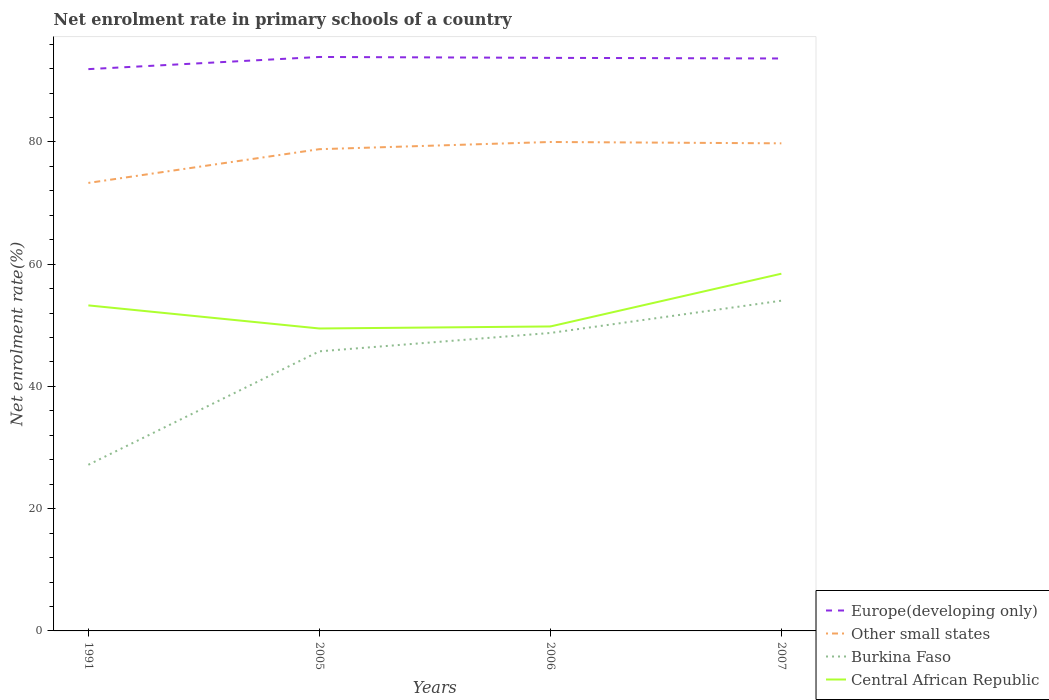Across all years, what is the maximum net enrolment rate in primary schools in Central African Republic?
Ensure brevity in your answer.  49.48. What is the total net enrolment rate in primary schools in Central African Republic in the graph?
Provide a short and direct response. 3.45. What is the difference between the highest and the second highest net enrolment rate in primary schools in Central African Republic?
Offer a terse response. 8.96. How many lines are there?
Your answer should be very brief. 4. How many years are there in the graph?
Make the answer very short. 4. Does the graph contain any zero values?
Give a very brief answer. No. Does the graph contain grids?
Your answer should be compact. No. How many legend labels are there?
Provide a short and direct response. 4. What is the title of the graph?
Provide a short and direct response. Net enrolment rate in primary schools of a country. Does "Portugal" appear as one of the legend labels in the graph?
Provide a short and direct response. No. What is the label or title of the X-axis?
Your answer should be compact. Years. What is the label or title of the Y-axis?
Keep it short and to the point. Net enrolment rate(%). What is the Net enrolment rate(%) in Europe(developing only) in 1991?
Make the answer very short. 91.91. What is the Net enrolment rate(%) in Other small states in 1991?
Offer a terse response. 73.29. What is the Net enrolment rate(%) in Burkina Faso in 1991?
Make the answer very short. 27.18. What is the Net enrolment rate(%) in Central African Republic in 1991?
Provide a succinct answer. 53.26. What is the Net enrolment rate(%) in Europe(developing only) in 2005?
Keep it short and to the point. 93.9. What is the Net enrolment rate(%) of Other small states in 2005?
Keep it short and to the point. 78.81. What is the Net enrolment rate(%) in Burkina Faso in 2005?
Your response must be concise. 45.74. What is the Net enrolment rate(%) of Central African Republic in 2005?
Your answer should be very brief. 49.48. What is the Net enrolment rate(%) in Europe(developing only) in 2006?
Make the answer very short. 93.76. What is the Net enrolment rate(%) in Other small states in 2006?
Ensure brevity in your answer.  79.99. What is the Net enrolment rate(%) in Burkina Faso in 2006?
Provide a succinct answer. 48.75. What is the Net enrolment rate(%) in Central African Republic in 2006?
Offer a very short reply. 49.81. What is the Net enrolment rate(%) of Europe(developing only) in 2007?
Your answer should be very brief. 93.65. What is the Net enrolment rate(%) of Other small states in 2007?
Your answer should be compact. 79.77. What is the Net enrolment rate(%) of Burkina Faso in 2007?
Your response must be concise. 54.03. What is the Net enrolment rate(%) of Central African Republic in 2007?
Your answer should be compact. 58.44. Across all years, what is the maximum Net enrolment rate(%) of Europe(developing only)?
Keep it short and to the point. 93.9. Across all years, what is the maximum Net enrolment rate(%) in Other small states?
Keep it short and to the point. 79.99. Across all years, what is the maximum Net enrolment rate(%) of Burkina Faso?
Provide a short and direct response. 54.03. Across all years, what is the maximum Net enrolment rate(%) of Central African Republic?
Provide a short and direct response. 58.44. Across all years, what is the minimum Net enrolment rate(%) of Europe(developing only)?
Provide a succinct answer. 91.91. Across all years, what is the minimum Net enrolment rate(%) of Other small states?
Give a very brief answer. 73.29. Across all years, what is the minimum Net enrolment rate(%) of Burkina Faso?
Give a very brief answer. 27.18. Across all years, what is the minimum Net enrolment rate(%) in Central African Republic?
Provide a succinct answer. 49.48. What is the total Net enrolment rate(%) of Europe(developing only) in the graph?
Provide a short and direct response. 373.22. What is the total Net enrolment rate(%) in Other small states in the graph?
Your answer should be compact. 311.87. What is the total Net enrolment rate(%) of Burkina Faso in the graph?
Offer a very short reply. 175.7. What is the total Net enrolment rate(%) of Central African Republic in the graph?
Your answer should be very brief. 210.99. What is the difference between the Net enrolment rate(%) of Europe(developing only) in 1991 and that in 2005?
Give a very brief answer. -1.99. What is the difference between the Net enrolment rate(%) of Other small states in 1991 and that in 2005?
Offer a very short reply. -5.52. What is the difference between the Net enrolment rate(%) of Burkina Faso in 1991 and that in 2005?
Give a very brief answer. -18.56. What is the difference between the Net enrolment rate(%) in Central African Republic in 1991 and that in 2005?
Your answer should be very brief. 3.78. What is the difference between the Net enrolment rate(%) of Europe(developing only) in 1991 and that in 2006?
Offer a very short reply. -1.84. What is the difference between the Net enrolment rate(%) in Other small states in 1991 and that in 2006?
Ensure brevity in your answer.  -6.7. What is the difference between the Net enrolment rate(%) of Burkina Faso in 1991 and that in 2006?
Offer a terse response. -21.57. What is the difference between the Net enrolment rate(%) of Central African Republic in 1991 and that in 2006?
Give a very brief answer. 3.45. What is the difference between the Net enrolment rate(%) of Europe(developing only) in 1991 and that in 2007?
Provide a short and direct response. -1.74. What is the difference between the Net enrolment rate(%) in Other small states in 1991 and that in 2007?
Your answer should be compact. -6.48. What is the difference between the Net enrolment rate(%) of Burkina Faso in 1991 and that in 2007?
Offer a very short reply. -26.84. What is the difference between the Net enrolment rate(%) in Central African Republic in 1991 and that in 2007?
Your answer should be very brief. -5.18. What is the difference between the Net enrolment rate(%) in Europe(developing only) in 2005 and that in 2006?
Ensure brevity in your answer.  0.15. What is the difference between the Net enrolment rate(%) in Other small states in 2005 and that in 2006?
Give a very brief answer. -1.18. What is the difference between the Net enrolment rate(%) in Burkina Faso in 2005 and that in 2006?
Your answer should be compact. -3. What is the difference between the Net enrolment rate(%) in Central African Republic in 2005 and that in 2006?
Keep it short and to the point. -0.33. What is the difference between the Net enrolment rate(%) in Europe(developing only) in 2005 and that in 2007?
Make the answer very short. 0.25. What is the difference between the Net enrolment rate(%) in Other small states in 2005 and that in 2007?
Provide a short and direct response. -0.96. What is the difference between the Net enrolment rate(%) in Burkina Faso in 2005 and that in 2007?
Ensure brevity in your answer.  -8.28. What is the difference between the Net enrolment rate(%) in Central African Republic in 2005 and that in 2007?
Offer a terse response. -8.96. What is the difference between the Net enrolment rate(%) in Europe(developing only) in 2006 and that in 2007?
Your response must be concise. 0.1. What is the difference between the Net enrolment rate(%) of Other small states in 2006 and that in 2007?
Give a very brief answer. 0.22. What is the difference between the Net enrolment rate(%) of Burkina Faso in 2006 and that in 2007?
Offer a terse response. -5.28. What is the difference between the Net enrolment rate(%) of Central African Republic in 2006 and that in 2007?
Give a very brief answer. -8.63. What is the difference between the Net enrolment rate(%) in Europe(developing only) in 1991 and the Net enrolment rate(%) in Other small states in 2005?
Ensure brevity in your answer.  13.1. What is the difference between the Net enrolment rate(%) in Europe(developing only) in 1991 and the Net enrolment rate(%) in Burkina Faso in 2005?
Your answer should be very brief. 46.17. What is the difference between the Net enrolment rate(%) of Europe(developing only) in 1991 and the Net enrolment rate(%) of Central African Republic in 2005?
Offer a very short reply. 42.43. What is the difference between the Net enrolment rate(%) in Other small states in 1991 and the Net enrolment rate(%) in Burkina Faso in 2005?
Make the answer very short. 27.55. What is the difference between the Net enrolment rate(%) in Other small states in 1991 and the Net enrolment rate(%) in Central African Republic in 2005?
Offer a very short reply. 23.81. What is the difference between the Net enrolment rate(%) of Burkina Faso in 1991 and the Net enrolment rate(%) of Central African Republic in 2005?
Your answer should be very brief. -22.3. What is the difference between the Net enrolment rate(%) in Europe(developing only) in 1991 and the Net enrolment rate(%) in Other small states in 2006?
Ensure brevity in your answer.  11.92. What is the difference between the Net enrolment rate(%) in Europe(developing only) in 1991 and the Net enrolment rate(%) in Burkina Faso in 2006?
Your answer should be compact. 43.16. What is the difference between the Net enrolment rate(%) in Europe(developing only) in 1991 and the Net enrolment rate(%) in Central African Republic in 2006?
Give a very brief answer. 42.1. What is the difference between the Net enrolment rate(%) of Other small states in 1991 and the Net enrolment rate(%) of Burkina Faso in 2006?
Provide a short and direct response. 24.55. What is the difference between the Net enrolment rate(%) of Other small states in 1991 and the Net enrolment rate(%) of Central African Republic in 2006?
Your answer should be very brief. 23.48. What is the difference between the Net enrolment rate(%) of Burkina Faso in 1991 and the Net enrolment rate(%) of Central African Republic in 2006?
Your response must be concise. -22.63. What is the difference between the Net enrolment rate(%) of Europe(developing only) in 1991 and the Net enrolment rate(%) of Other small states in 2007?
Your response must be concise. 12.14. What is the difference between the Net enrolment rate(%) of Europe(developing only) in 1991 and the Net enrolment rate(%) of Burkina Faso in 2007?
Give a very brief answer. 37.88. What is the difference between the Net enrolment rate(%) in Europe(developing only) in 1991 and the Net enrolment rate(%) in Central African Republic in 2007?
Make the answer very short. 33.47. What is the difference between the Net enrolment rate(%) in Other small states in 1991 and the Net enrolment rate(%) in Burkina Faso in 2007?
Offer a very short reply. 19.27. What is the difference between the Net enrolment rate(%) in Other small states in 1991 and the Net enrolment rate(%) in Central African Republic in 2007?
Offer a terse response. 14.85. What is the difference between the Net enrolment rate(%) in Burkina Faso in 1991 and the Net enrolment rate(%) in Central African Republic in 2007?
Offer a very short reply. -31.26. What is the difference between the Net enrolment rate(%) in Europe(developing only) in 2005 and the Net enrolment rate(%) in Other small states in 2006?
Your response must be concise. 13.91. What is the difference between the Net enrolment rate(%) in Europe(developing only) in 2005 and the Net enrolment rate(%) in Burkina Faso in 2006?
Provide a succinct answer. 45.15. What is the difference between the Net enrolment rate(%) in Europe(developing only) in 2005 and the Net enrolment rate(%) in Central African Republic in 2006?
Your answer should be compact. 44.09. What is the difference between the Net enrolment rate(%) in Other small states in 2005 and the Net enrolment rate(%) in Burkina Faso in 2006?
Offer a very short reply. 30.07. What is the difference between the Net enrolment rate(%) of Other small states in 2005 and the Net enrolment rate(%) of Central African Republic in 2006?
Provide a short and direct response. 29. What is the difference between the Net enrolment rate(%) in Burkina Faso in 2005 and the Net enrolment rate(%) in Central African Republic in 2006?
Your answer should be very brief. -4.07. What is the difference between the Net enrolment rate(%) of Europe(developing only) in 2005 and the Net enrolment rate(%) of Other small states in 2007?
Offer a terse response. 14.13. What is the difference between the Net enrolment rate(%) in Europe(developing only) in 2005 and the Net enrolment rate(%) in Burkina Faso in 2007?
Your response must be concise. 39.88. What is the difference between the Net enrolment rate(%) in Europe(developing only) in 2005 and the Net enrolment rate(%) in Central African Republic in 2007?
Give a very brief answer. 35.46. What is the difference between the Net enrolment rate(%) of Other small states in 2005 and the Net enrolment rate(%) of Burkina Faso in 2007?
Ensure brevity in your answer.  24.79. What is the difference between the Net enrolment rate(%) in Other small states in 2005 and the Net enrolment rate(%) in Central African Republic in 2007?
Provide a succinct answer. 20.37. What is the difference between the Net enrolment rate(%) in Burkina Faso in 2005 and the Net enrolment rate(%) in Central African Republic in 2007?
Your answer should be compact. -12.7. What is the difference between the Net enrolment rate(%) in Europe(developing only) in 2006 and the Net enrolment rate(%) in Other small states in 2007?
Your response must be concise. 13.98. What is the difference between the Net enrolment rate(%) of Europe(developing only) in 2006 and the Net enrolment rate(%) of Burkina Faso in 2007?
Provide a succinct answer. 39.73. What is the difference between the Net enrolment rate(%) of Europe(developing only) in 2006 and the Net enrolment rate(%) of Central African Republic in 2007?
Provide a short and direct response. 35.31. What is the difference between the Net enrolment rate(%) in Other small states in 2006 and the Net enrolment rate(%) in Burkina Faso in 2007?
Make the answer very short. 25.97. What is the difference between the Net enrolment rate(%) of Other small states in 2006 and the Net enrolment rate(%) of Central African Republic in 2007?
Offer a very short reply. 21.55. What is the difference between the Net enrolment rate(%) in Burkina Faso in 2006 and the Net enrolment rate(%) in Central African Republic in 2007?
Offer a terse response. -9.7. What is the average Net enrolment rate(%) of Europe(developing only) per year?
Make the answer very short. 93.31. What is the average Net enrolment rate(%) in Other small states per year?
Your answer should be very brief. 77.97. What is the average Net enrolment rate(%) of Burkina Faso per year?
Provide a succinct answer. 43.92. What is the average Net enrolment rate(%) of Central African Republic per year?
Your response must be concise. 52.75. In the year 1991, what is the difference between the Net enrolment rate(%) of Europe(developing only) and Net enrolment rate(%) of Other small states?
Provide a succinct answer. 18.62. In the year 1991, what is the difference between the Net enrolment rate(%) in Europe(developing only) and Net enrolment rate(%) in Burkina Faso?
Offer a very short reply. 64.73. In the year 1991, what is the difference between the Net enrolment rate(%) of Europe(developing only) and Net enrolment rate(%) of Central African Republic?
Your response must be concise. 38.65. In the year 1991, what is the difference between the Net enrolment rate(%) of Other small states and Net enrolment rate(%) of Burkina Faso?
Provide a short and direct response. 46.11. In the year 1991, what is the difference between the Net enrolment rate(%) of Other small states and Net enrolment rate(%) of Central African Republic?
Your answer should be compact. 20.04. In the year 1991, what is the difference between the Net enrolment rate(%) in Burkina Faso and Net enrolment rate(%) in Central African Republic?
Your answer should be very brief. -26.08. In the year 2005, what is the difference between the Net enrolment rate(%) of Europe(developing only) and Net enrolment rate(%) of Other small states?
Your answer should be very brief. 15.09. In the year 2005, what is the difference between the Net enrolment rate(%) of Europe(developing only) and Net enrolment rate(%) of Burkina Faso?
Keep it short and to the point. 48.16. In the year 2005, what is the difference between the Net enrolment rate(%) in Europe(developing only) and Net enrolment rate(%) in Central African Republic?
Ensure brevity in your answer.  44.42. In the year 2005, what is the difference between the Net enrolment rate(%) in Other small states and Net enrolment rate(%) in Burkina Faso?
Your response must be concise. 33.07. In the year 2005, what is the difference between the Net enrolment rate(%) in Other small states and Net enrolment rate(%) in Central African Republic?
Your answer should be compact. 29.33. In the year 2005, what is the difference between the Net enrolment rate(%) in Burkina Faso and Net enrolment rate(%) in Central African Republic?
Offer a terse response. -3.74. In the year 2006, what is the difference between the Net enrolment rate(%) in Europe(developing only) and Net enrolment rate(%) in Other small states?
Provide a succinct answer. 13.76. In the year 2006, what is the difference between the Net enrolment rate(%) in Europe(developing only) and Net enrolment rate(%) in Burkina Faso?
Keep it short and to the point. 45.01. In the year 2006, what is the difference between the Net enrolment rate(%) of Europe(developing only) and Net enrolment rate(%) of Central African Republic?
Make the answer very short. 43.94. In the year 2006, what is the difference between the Net enrolment rate(%) of Other small states and Net enrolment rate(%) of Burkina Faso?
Keep it short and to the point. 31.25. In the year 2006, what is the difference between the Net enrolment rate(%) of Other small states and Net enrolment rate(%) of Central African Republic?
Provide a short and direct response. 30.18. In the year 2006, what is the difference between the Net enrolment rate(%) in Burkina Faso and Net enrolment rate(%) in Central African Republic?
Keep it short and to the point. -1.06. In the year 2007, what is the difference between the Net enrolment rate(%) in Europe(developing only) and Net enrolment rate(%) in Other small states?
Provide a succinct answer. 13.88. In the year 2007, what is the difference between the Net enrolment rate(%) in Europe(developing only) and Net enrolment rate(%) in Burkina Faso?
Your answer should be very brief. 39.63. In the year 2007, what is the difference between the Net enrolment rate(%) of Europe(developing only) and Net enrolment rate(%) of Central African Republic?
Give a very brief answer. 35.21. In the year 2007, what is the difference between the Net enrolment rate(%) of Other small states and Net enrolment rate(%) of Burkina Faso?
Your answer should be compact. 25.74. In the year 2007, what is the difference between the Net enrolment rate(%) of Other small states and Net enrolment rate(%) of Central African Republic?
Provide a short and direct response. 21.33. In the year 2007, what is the difference between the Net enrolment rate(%) in Burkina Faso and Net enrolment rate(%) in Central African Republic?
Keep it short and to the point. -4.42. What is the ratio of the Net enrolment rate(%) of Europe(developing only) in 1991 to that in 2005?
Make the answer very short. 0.98. What is the ratio of the Net enrolment rate(%) in Burkina Faso in 1991 to that in 2005?
Your answer should be very brief. 0.59. What is the ratio of the Net enrolment rate(%) in Central African Republic in 1991 to that in 2005?
Make the answer very short. 1.08. What is the ratio of the Net enrolment rate(%) in Europe(developing only) in 1991 to that in 2006?
Ensure brevity in your answer.  0.98. What is the ratio of the Net enrolment rate(%) in Other small states in 1991 to that in 2006?
Provide a succinct answer. 0.92. What is the ratio of the Net enrolment rate(%) in Burkina Faso in 1991 to that in 2006?
Provide a succinct answer. 0.56. What is the ratio of the Net enrolment rate(%) of Central African Republic in 1991 to that in 2006?
Keep it short and to the point. 1.07. What is the ratio of the Net enrolment rate(%) in Europe(developing only) in 1991 to that in 2007?
Your answer should be compact. 0.98. What is the ratio of the Net enrolment rate(%) of Other small states in 1991 to that in 2007?
Keep it short and to the point. 0.92. What is the ratio of the Net enrolment rate(%) in Burkina Faso in 1991 to that in 2007?
Offer a very short reply. 0.5. What is the ratio of the Net enrolment rate(%) in Central African Republic in 1991 to that in 2007?
Your response must be concise. 0.91. What is the ratio of the Net enrolment rate(%) of Europe(developing only) in 2005 to that in 2006?
Ensure brevity in your answer.  1. What is the ratio of the Net enrolment rate(%) of Other small states in 2005 to that in 2006?
Keep it short and to the point. 0.99. What is the ratio of the Net enrolment rate(%) of Burkina Faso in 2005 to that in 2006?
Your response must be concise. 0.94. What is the ratio of the Net enrolment rate(%) of Central African Republic in 2005 to that in 2006?
Make the answer very short. 0.99. What is the ratio of the Net enrolment rate(%) in Other small states in 2005 to that in 2007?
Make the answer very short. 0.99. What is the ratio of the Net enrolment rate(%) in Burkina Faso in 2005 to that in 2007?
Your response must be concise. 0.85. What is the ratio of the Net enrolment rate(%) of Central African Republic in 2005 to that in 2007?
Provide a short and direct response. 0.85. What is the ratio of the Net enrolment rate(%) in Burkina Faso in 2006 to that in 2007?
Your response must be concise. 0.9. What is the ratio of the Net enrolment rate(%) in Central African Republic in 2006 to that in 2007?
Offer a very short reply. 0.85. What is the difference between the highest and the second highest Net enrolment rate(%) of Europe(developing only)?
Provide a succinct answer. 0.15. What is the difference between the highest and the second highest Net enrolment rate(%) in Other small states?
Ensure brevity in your answer.  0.22. What is the difference between the highest and the second highest Net enrolment rate(%) of Burkina Faso?
Provide a short and direct response. 5.28. What is the difference between the highest and the second highest Net enrolment rate(%) of Central African Republic?
Offer a very short reply. 5.18. What is the difference between the highest and the lowest Net enrolment rate(%) in Europe(developing only)?
Make the answer very short. 1.99. What is the difference between the highest and the lowest Net enrolment rate(%) in Other small states?
Your answer should be very brief. 6.7. What is the difference between the highest and the lowest Net enrolment rate(%) in Burkina Faso?
Provide a short and direct response. 26.84. What is the difference between the highest and the lowest Net enrolment rate(%) in Central African Republic?
Give a very brief answer. 8.96. 